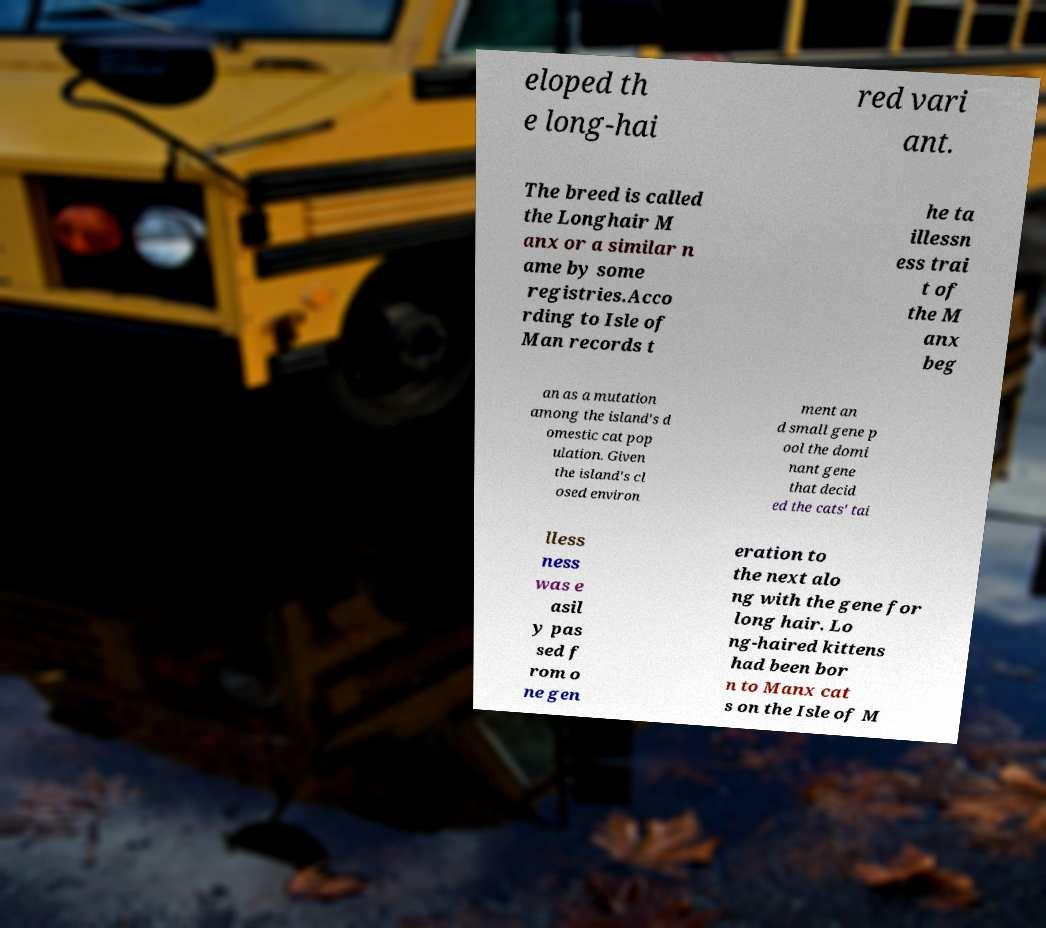Can you read and provide the text displayed in the image?This photo seems to have some interesting text. Can you extract and type it out for me? eloped th e long-hai red vari ant. The breed is called the Longhair M anx or a similar n ame by some registries.Acco rding to Isle of Man records t he ta illessn ess trai t of the M anx beg an as a mutation among the island's d omestic cat pop ulation. Given the island's cl osed environ ment an d small gene p ool the domi nant gene that decid ed the cats' tai lless ness was e asil y pas sed f rom o ne gen eration to the next alo ng with the gene for long hair. Lo ng-haired kittens had been bor n to Manx cat s on the Isle of M 